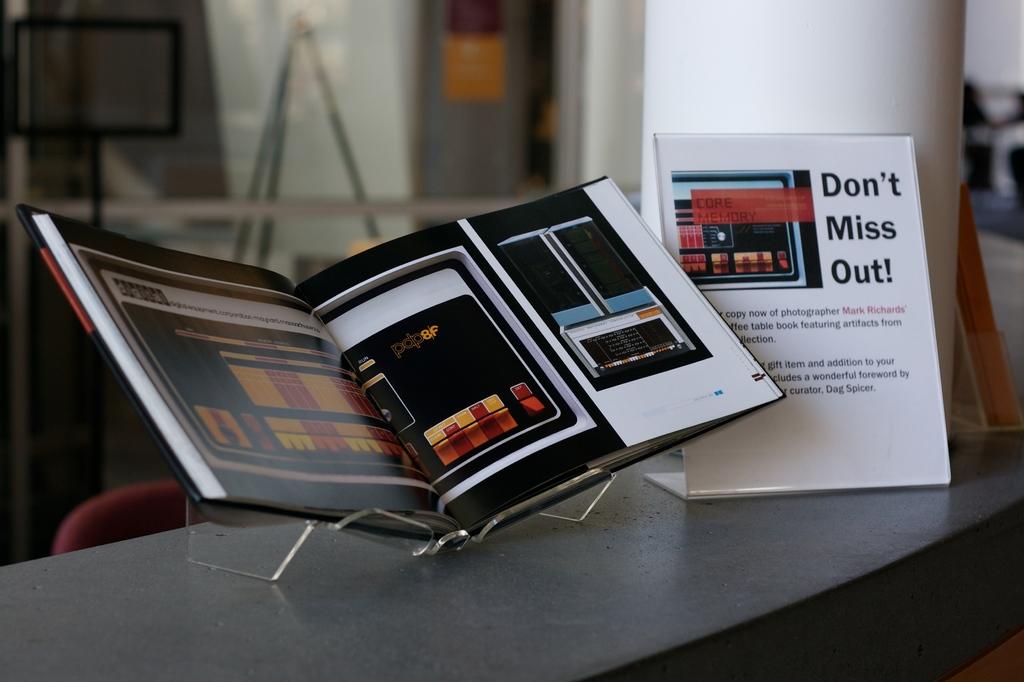What does that display say?
Make the answer very short. Don't miss out!. 